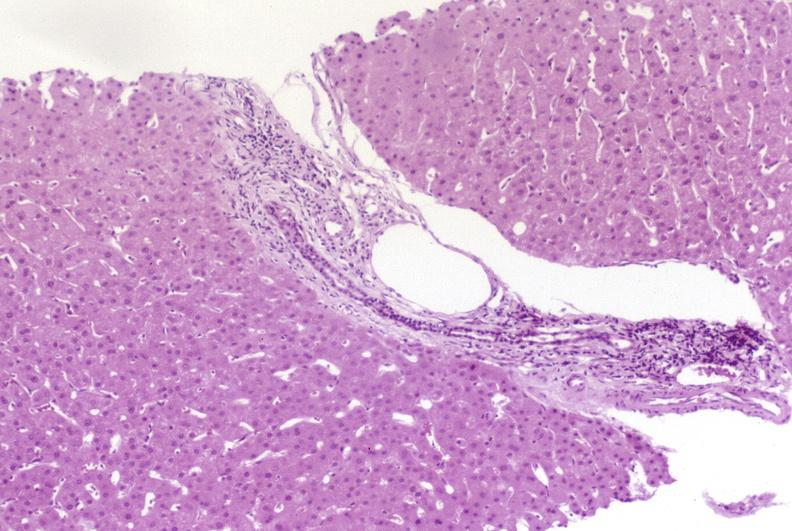s liver present?
Answer the question using a single word or phrase. Yes 